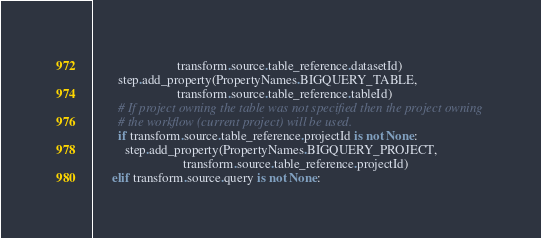Convert code to text. <code><loc_0><loc_0><loc_500><loc_500><_Python_>                          transform.source.table_reference.datasetId)
        step.add_property(PropertyNames.BIGQUERY_TABLE,
                          transform.source.table_reference.tableId)
        # If project owning the table was not specified then the project owning
        # the workflow (current project) will be used.
        if transform.source.table_reference.projectId is not None:
          step.add_property(PropertyNames.BIGQUERY_PROJECT,
                            transform.source.table_reference.projectId)
      elif transform.source.query is not None:</code> 